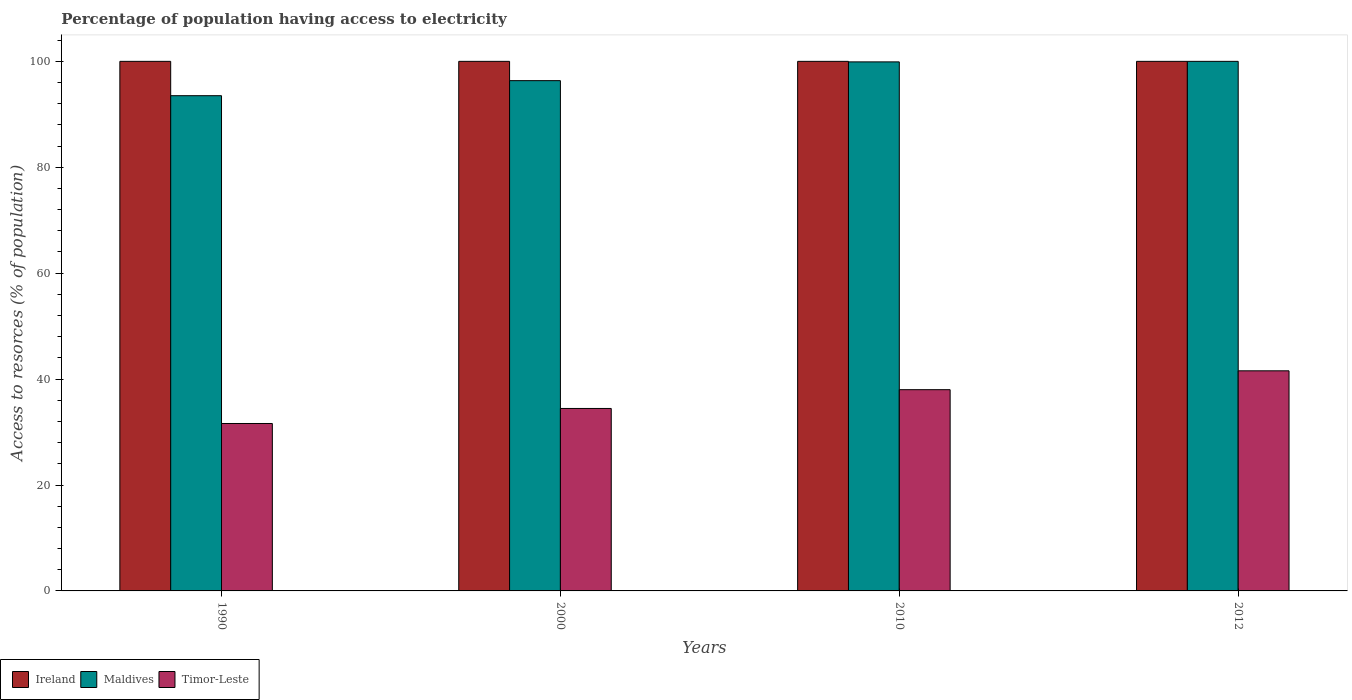Are the number of bars per tick equal to the number of legend labels?
Make the answer very short. Yes. Are the number of bars on each tick of the X-axis equal?
Provide a succinct answer. Yes. How many bars are there on the 4th tick from the left?
Keep it short and to the point. 3. How many bars are there on the 1st tick from the right?
Provide a succinct answer. 3. What is the label of the 2nd group of bars from the left?
Offer a very short reply. 2000. What is the percentage of population having access to electricity in Ireland in 2010?
Ensure brevity in your answer.  100. Across all years, what is the maximum percentage of population having access to electricity in Ireland?
Make the answer very short. 100. Across all years, what is the minimum percentage of population having access to electricity in Timor-Leste?
Provide a succinct answer. 31.62. What is the total percentage of population having access to electricity in Ireland in the graph?
Make the answer very short. 400. What is the difference between the percentage of population having access to electricity in Ireland in 2010 and that in 2012?
Give a very brief answer. 0. What is the difference between the percentage of population having access to electricity in Timor-Leste in 2010 and the percentage of population having access to electricity in Maldives in 2012?
Make the answer very short. -62. In the year 2000, what is the difference between the percentage of population having access to electricity in Ireland and percentage of population having access to electricity in Timor-Leste?
Make the answer very short. 65.54. What is the ratio of the percentage of population having access to electricity in Timor-Leste in 1990 to that in 2012?
Offer a very short reply. 0.76. Is the percentage of population having access to electricity in Timor-Leste in 2000 less than that in 2012?
Your answer should be compact. Yes. Is the difference between the percentage of population having access to electricity in Ireland in 1990 and 2010 greater than the difference between the percentage of population having access to electricity in Timor-Leste in 1990 and 2010?
Ensure brevity in your answer.  Yes. What is the difference between the highest and the second highest percentage of population having access to electricity in Maldives?
Your answer should be compact. 0.1. What is the difference between the highest and the lowest percentage of population having access to electricity in Maldives?
Provide a succinct answer. 6.48. Is the sum of the percentage of population having access to electricity in Maldives in 2010 and 2012 greater than the maximum percentage of population having access to electricity in Ireland across all years?
Provide a short and direct response. Yes. What does the 1st bar from the left in 2012 represents?
Your answer should be compact. Ireland. What does the 1st bar from the right in 2010 represents?
Ensure brevity in your answer.  Timor-Leste. How many bars are there?
Give a very brief answer. 12. What is the title of the graph?
Make the answer very short. Percentage of population having access to electricity. Does "United Kingdom" appear as one of the legend labels in the graph?
Ensure brevity in your answer.  No. What is the label or title of the Y-axis?
Your answer should be compact. Access to resorces (% of population). What is the Access to resorces (% of population) of Ireland in 1990?
Offer a terse response. 100. What is the Access to resorces (% of population) in Maldives in 1990?
Make the answer very short. 93.52. What is the Access to resorces (% of population) in Timor-Leste in 1990?
Your answer should be compact. 31.62. What is the Access to resorces (% of population) in Maldives in 2000?
Your response must be concise. 96.36. What is the Access to resorces (% of population) of Timor-Leste in 2000?
Your answer should be very brief. 34.46. What is the Access to resorces (% of population) in Maldives in 2010?
Your response must be concise. 99.9. What is the Access to resorces (% of population) of Timor-Leste in 2012?
Ensure brevity in your answer.  41.56. Across all years, what is the maximum Access to resorces (% of population) of Ireland?
Give a very brief answer. 100. Across all years, what is the maximum Access to resorces (% of population) of Timor-Leste?
Make the answer very short. 41.56. Across all years, what is the minimum Access to resorces (% of population) of Maldives?
Give a very brief answer. 93.52. Across all years, what is the minimum Access to resorces (% of population) of Timor-Leste?
Keep it short and to the point. 31.62. What is the total Access to resorces (% of population) in Maldives in the graph?
Provide a succinct answer. 389.77. What is the total Access to resorces (% of population) in Timor-Leste in the graph?
Give a very brief answer. 145.63. What is the difference between the Access to resorces (% of population) in Ireland in 1990 and that in 2000?
Provide a short and direct response. 0. What is the difference between the Access to resorces (% of population) in Maldives in 1990 and that in 2000?
Offer a terse response. -2.84. What is the difference between the Access to resorces (% of population) of Timor-Leste in 1990 and that in 2000?
Keep it short and to the point. -2.84. What is the difference between the Access to resorces (% of population) in Maldives in 1990 and that in 2010?
Offer a terse response. -6.38. What is the difference between the Access to resorces (% of population) in Timor-Leste in 1990 and that in 2010?
Give a very brief answer. -6.38. What is the difference between the Access to resorces (% of population) of Ireland in 1990 and that in 2012?
Offer a terse response. 0. What is the difference between the Access to resorces (% of population) in Maldives in 1990 and that in 2012?
Keep it short and to the point. -6.48. What is the difference between the Access to resorces (% of population) of Timor-Leste in 1990 and that in 2012?
Give a very brief answer. -9.95. What is the difference between the Access to resorces (% of population) in Maldives in 2000 and that in 2010?
Provide a short and direct response. -3.54. What is the difference between the Access to resorces (% of population) in Timor-Leste in 2000 and that in 2010?
Your response must be concise. -3.54. What is the difference between the Access to resorces (% of population) in Maldives in 2000 and that in 2012?
Give a very brief answer. -3.64. What is the difference between the Access to resorces (% of population) in Timor-Leste in 2000 and that in 2012?
Provide a succinct answer. -7.11. What is the difference between the Access to resorces (% of population) in Ireland in 2010 and that in 2012?
Make the answer very short. 0. What is the difference between the Access to resorces (% of population) in Timor-Leste in 2010 and that in 2012?
Give a very brief answer. -3.56. What is the difference between the Access to resorces (% of population) of Ireland in 1990 and the Access to resorces (% of population) of Maldives in 2000?
Make the answer very short. 3.64. What is the difference between the Access to resorces (% of population) in Ireland in 1990 and the Access to resorces (% of population) in Timor-Leste in 2000?
Your response must be concise. 65.54. What is the difference between the Access to resorces (% of population) of Maldives in 1990 and the Access to resorces (% of population) of Timor-Leste in 2000?
Ensure brevity in your answer.  59.06. What is the difference between the Access to resorces (% of population) in Maldives in 1990 and the Access to resorces (% of population) in Timor-Leste in 2010?
Ensure brevity in your answer.  55.52. What is the difference between the Access to resorces (% of population) of Ireland in 1990 and the Access to resorces (% of population) of Maldives in 2012?
Offer a terse response. 0. What is the difference between the Access to resorces (% of population) of Ireland in 1990 and the Access to resorces (% of population) of Timor-Leste in 2012?
Provide a succinct answer. 58.44. What is the difference between the Access to resorces (% of population) in Maldives in 1990 and the Access to resorces (% of population) in Timor-Leste in 2012?
Provide a short and direct response. 51.95. What is the difference between the Access to resorces (% of population) of Ireland in 2000 and the Access to resorces (% of population) of Timor-Leste in 2010?
Keep it short and to the point. 62. What is the difference between the Access to resorces (% of population) of Maldives in 2000 and the Access to resorces (% of population) of Timor-Leste in 2010?
Provide a short and direct response. 58.36. What is the difference between the Access to resorces (% of population) of Ireland in 2000 and the Access to resorces (% of population) of Timor-Leste in 2012?
Keep it short and to the point. 58.44. What is the difference between the Access to resorces (% of population) in Maldives in 2000 and the Access to resorces (% of population) in Timor-Leste in 2012?
Your answer should be very brief. 54.79. What is the difference between the Access to resorces (% of population) in Ireland in 2010 and the Access to resorces (% of population) in Timor-Leste in 2012?
Ensure brevity in your answer.  58.44. What is the difference between the Access to resorces (% of population) in Maldives in 2010 and the Access to resorces (% of population) in Timor-Leste in 2012?
Provide a succinct answer. 58.34. What is the average Access to resorces (% of population) in Ireland per year?
Offer a terse response. 100. What is the average Access to resorces (% of population) of Maldives per year?
Provide a succinct answer. 97.44. What is the average Access to resorces (% of population) in Timor-Leste per year?
Offer a very short reply. 36.41. In the year 1990, what is the difference between the Access to resorces (% of population) in Ireland and Access to resorces (% of population) in Maldives?
Provide a short and direct response. 6.48. In the year 1990, what is the difference between the Access to resorces (% of population) of Ireland and Access to resorces (% of population) of Timor-Leste?
Your answer should be compact. 68.38. In the year 1990, what is the difference between the Access to resorces (% of population) of Maldives and Access to resorces (% of population) of Timor-Leste?
Your answer should be compact. 61.9. In the year 2000, what is the difference between the Access to resorces (% of population) in Ireland and Access to resorces (% of population) in Maldives?
Ensure brevity in your answer.  3.64. In the year 2000, what is the difference between the Access to resorces (% of population) in Ireland and Access to resorces (% of population) in Timor-Leste?
Offer a terse response. 65.54. In the year 2000, what is the difference between the Access to resorces (% of population) of Maldives and Access to resorces (% of population) of Timor-Leste?
Provide a short and direct response. 61.9. In the year 2010, what is the difference between the Access to resorces (% of population) of Ireland and Access to resorces (% of population) of Maldives?
Keep it short and to the point. 0.1. In the year 2010, what is the difference between the Access to resorces (% of population) of Maldives and Access to resorces (% of population) of Timor-Leste?
Offer a very short reply. 61.9. In the year 2012, what is the difference between the Access to resorces (% of population) in Ireland and Access to resorces (% of population) in Maldives?
Your answer should be very brief. 0. In the year 2012, what is the difference between the Access to resorces (% of population) in Ireland and Access to resorces (% of population) in Timor-Leste?
Ensure brevity in your answer.  58.44. In the year 2012, what is the difference between the Access to resorces (% of population) in Maldives and Access to resorces (% of population) in Timor-Leste?
Provide a succinct answer. 58.44. What is the ratio of the Access to resorces (% of population) in Maldives in 1990 to that in 2000?
Your response must be concise. 0.97. What is the ratio of the Access to resorces (% of population) in Timor-Leste in 1990 to that in 2000?
Your response must be concise. 0.92. What is the ratio of the Access to resorces (% of population) of Ireland in 1990 to that in 2010?
Keep it short and to the point. 1. What is the ratio of the Access to resorces (% of population) in Maldives in 1990 to that in 2010?
Offer a terse response. 0.94. What is the ratio of the Access to resorces (% of population) of Timor-Leste in 1990 to that in 2010?
Offer a very short reply. 0.83. What is the ratio of the Access to resorces (% of population) of Maldives in 1990 to that in 2012?
Keep it short and to the point. 0.94. What is the ratio of the Access to resorces (% of population) of Timor-Leste in 1990 to that in 2012?
Provide a succinct answer. 0.76. What is the ratio of the Access to resorces (% of population) in Ireland in 2000 to that in 2010?
Your response must be concise. 1. What is the ratio of the Access to resorces (% of population) of Maldives in 2000 to that in 2010?
Ensure brevity in your answer.  0.96. What is the ratio of the Access to resorces (% of population) in Timor-Leste in 2000 to that in 2010?
Provide a succinct answer. 0.91. What is the ratio of the Access to resorces (% of population) in Ireland in 2000 to that in 2012?
Make the answer very short. 1. What is the ratio of the Access to resorces (% of population) in Maldives in 2000 to that in 2012?
Offer a terse response. 0.96. What is the ratio of the Access to resorces (% of population) of Timor-Leste in 2000 to that in 2012?
Ensure brevity in your answer.  0.83. What is the ratio of the Access to resorces (% of population) of Timor-Leste in 2010 to that in 2012?
Your response must be concise. 0.91. What is the difference between the highest and the second highest Access to resorces (% of population) of Ireland?
Your answer should be compact. 0. What is the difference between the highest and the second highest Access to resorces (% of population) of Timor-Leste?
Ensure brevity in your answer.  3.56. What is the difference between the highest and the lowest Access to resorces (% of population) of Maldives?
Your answer should be very brief. 6.48. What is the difference between the highest and the lowest Access to resorces (% of population) of Timor-Leste?
Give a very brief answer. 9.95. 